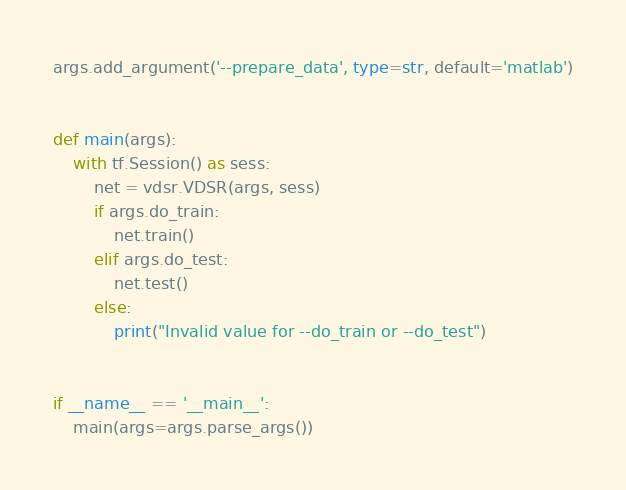<code> <loc_0><loc_0><loc_500><loc_500><_Python_>args.add_argument('--prepare_data', type=str, default='matlab')


def main(args):
    with tf.Session() as sess:
        net = vdsr.VDSR(args, sess)
        if args.do_train:
            net.train()
        elif args.do_test:
            net.test()
        else:
            print("Invalid value for --do_train or --do_test")


if __name__ == '__main__':
    main(args=args.parse_args())
</code> 